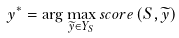Convert formula to latex. <formula><loc_0><loc_0><loc_500><loc_500>y ^ { * } = \arg \max _ { \widetilde { y } \in Y _ { S } } s c o r e \left ( S , \widetilde { y } \right )</formula> 